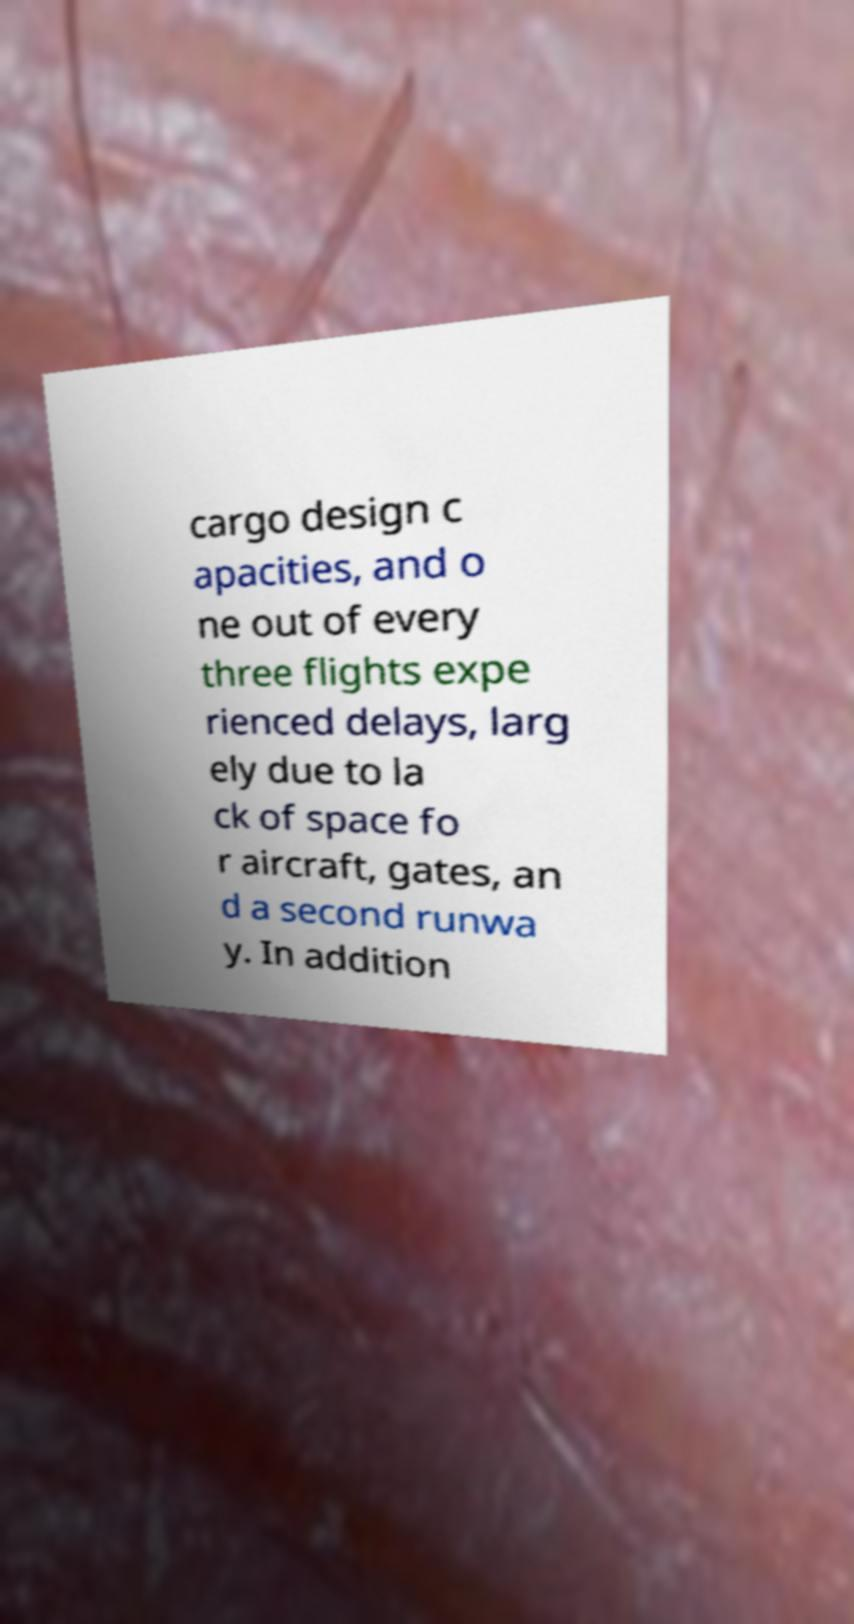Could you assist in decoding the text presented in this image and type it out clearly? cargo design c apacities, and o ne out of every three flights expe rienced delays, larg ely due to la ck of space fo r aircraft, gates, an d a second runwa y. In addition 